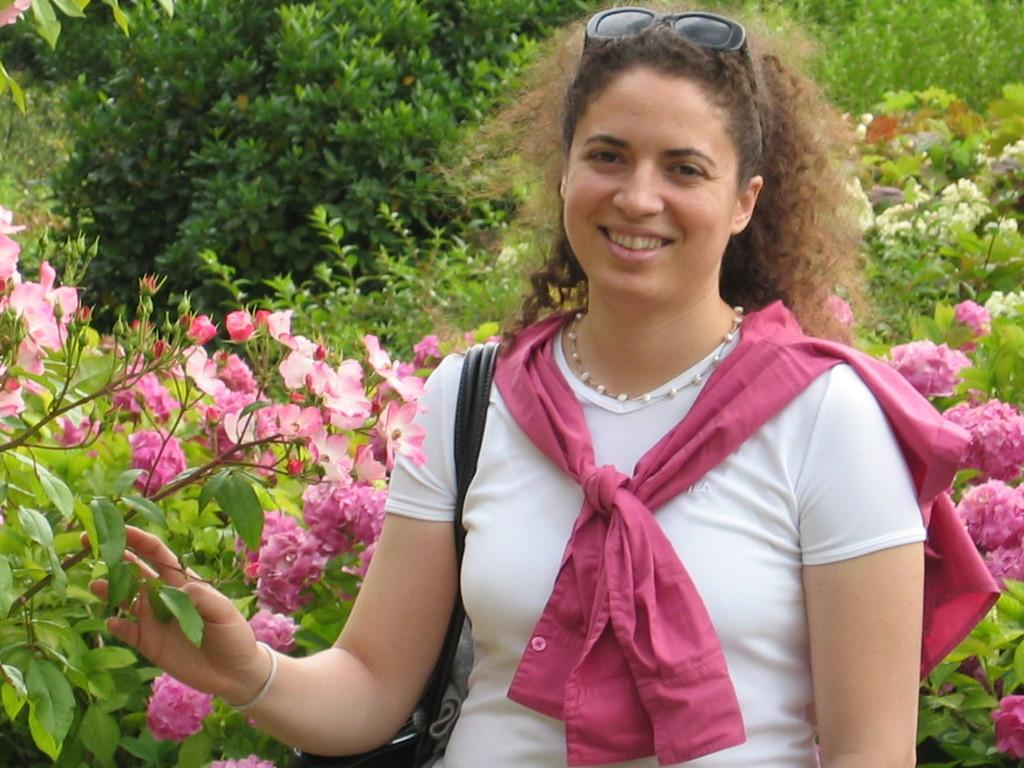Who is the main subject in the image? There is a lady in the image. What is the lady holding in the image? The lady is holding a stem with flowers. What type of vegetation can be seen in the image? There are trees with flowers and plants with flowers in the image. What type of jeans is the lady wearing in the image? There is no mention of jeans in the image, as the lady is holding a stem with flowers and there is no reference to her clothing. 